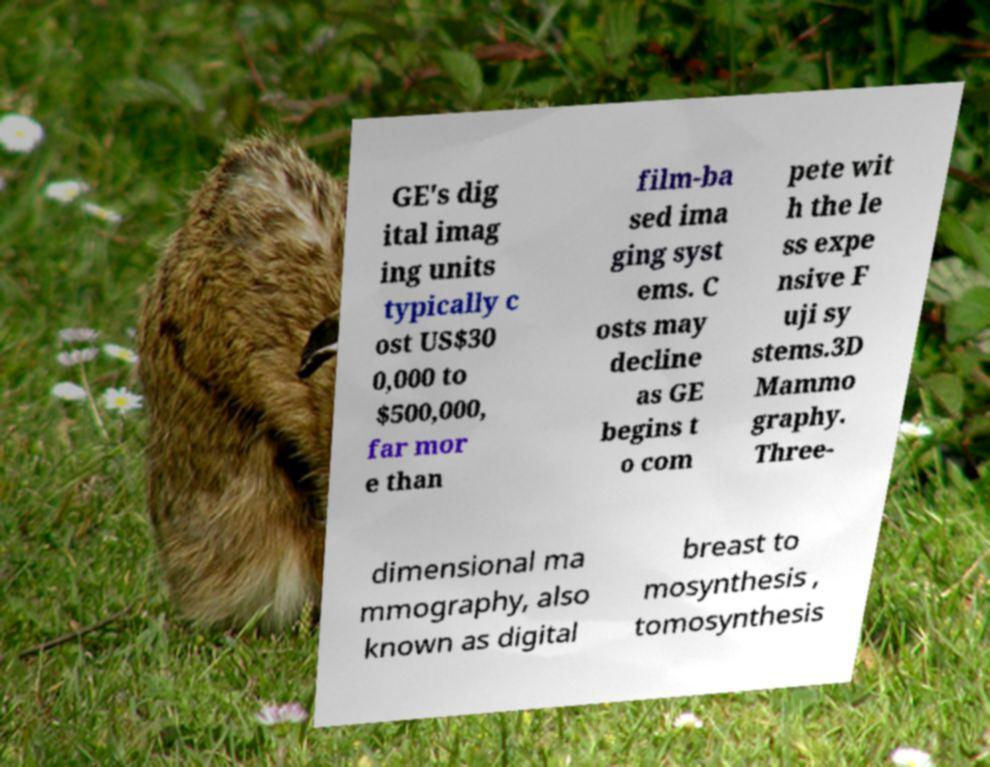Please read and relay the text visible in this image. What does it say? GE's dig ital imag ing units typically c ost US$30 0,000 to $500,000, far mor e than film-ba sed ima ging syst ems. C osts may decline as GE begins t o com pete wit h the le ss expe nsive F uji sy stems.3D Mammo graphy. Three- dimensional ma mmography, also known as digital breast to mosynthesis , tomosynthesis 